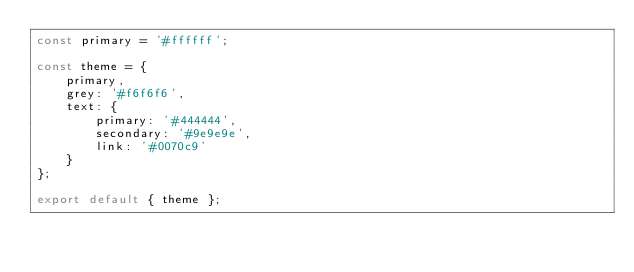<code> <loc_0><loc_0><loc_500><loc_500><_JavaScript_>const primary = '#ffffff';

const theme = {
	primary,
	grey: '#f6f6f6',
	text: {
		primary: '#444444',
		secondary: '#9e9e9e',
		link: '#0070c9'
	}
};

export default { theme };
</code> 